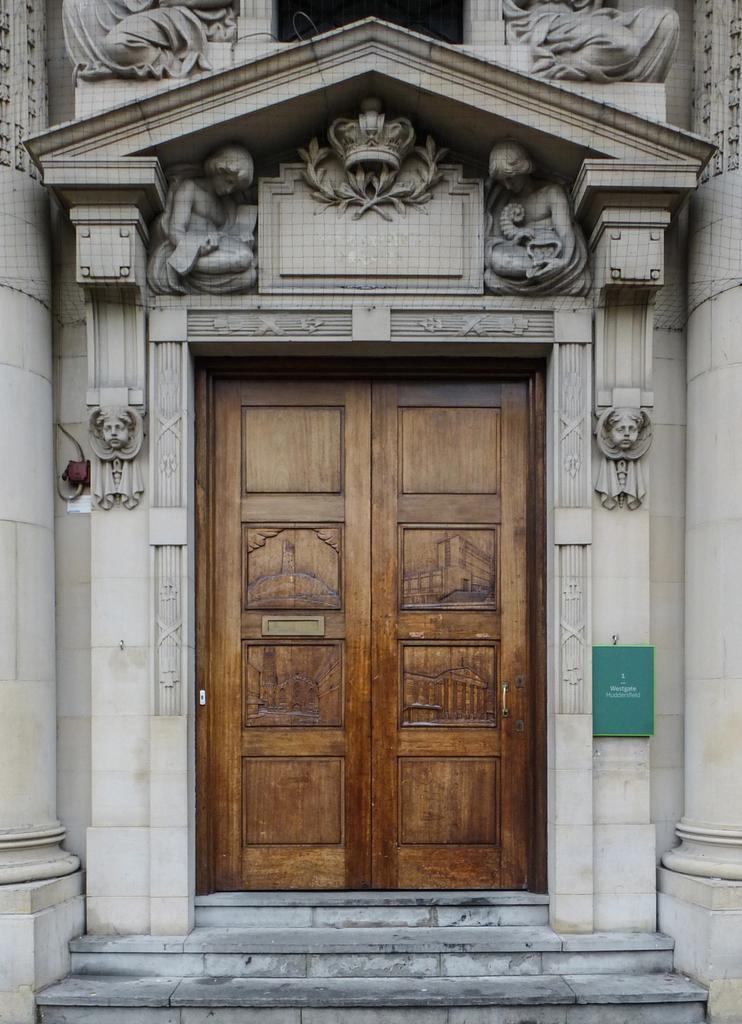How would you summarize this image in a sentence or two? In this image I can see few stairs, the building and few sculptures to the building. I can see a huge brown colored door. 